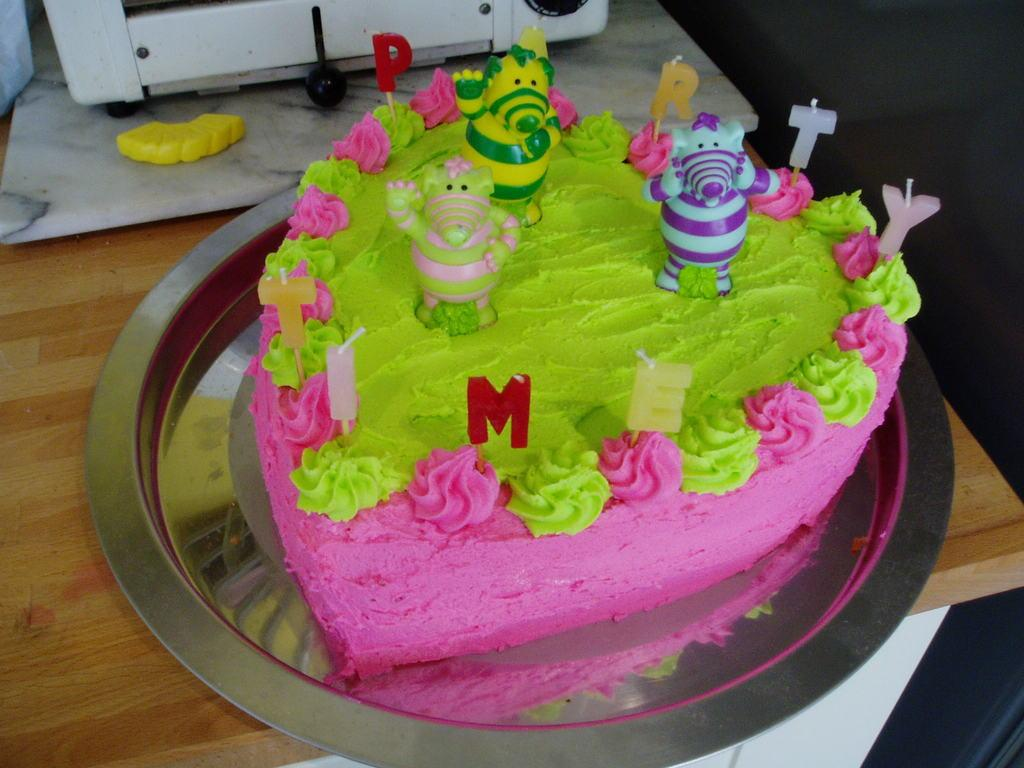What is the main object on the plate in the image? There is a cake on a plate in the image. What is unique about the candles on the cake? The cake has letter candles. What other items can be seen on the table? There are toys on the table. What is located at the top of the image? There is a device at the top of the image. What type of silver material can be seen on the cake in the image? There is no silver material visible on the cake in the image. How many flies are sitting on the toys in the image? There are no flies present in the image; only the cake, letter candles, toys, and device can be seen. 